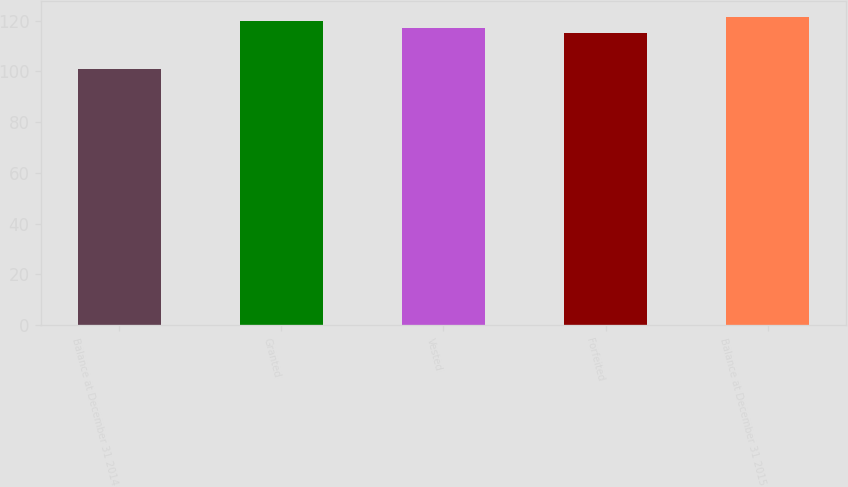<chart> <loc_0><loc_0><loc_500><loc_500><bar_chart><fcel>Balance at December 31 2014<fcel>Granted<fcel>Vested<fcel>Forfeited<fcel>Balance at December 31 2015<nl><fcel>100.85<fcel>119.64<fcel>117.17<fcel>115.24<fcel>121.52<nl></chart> 